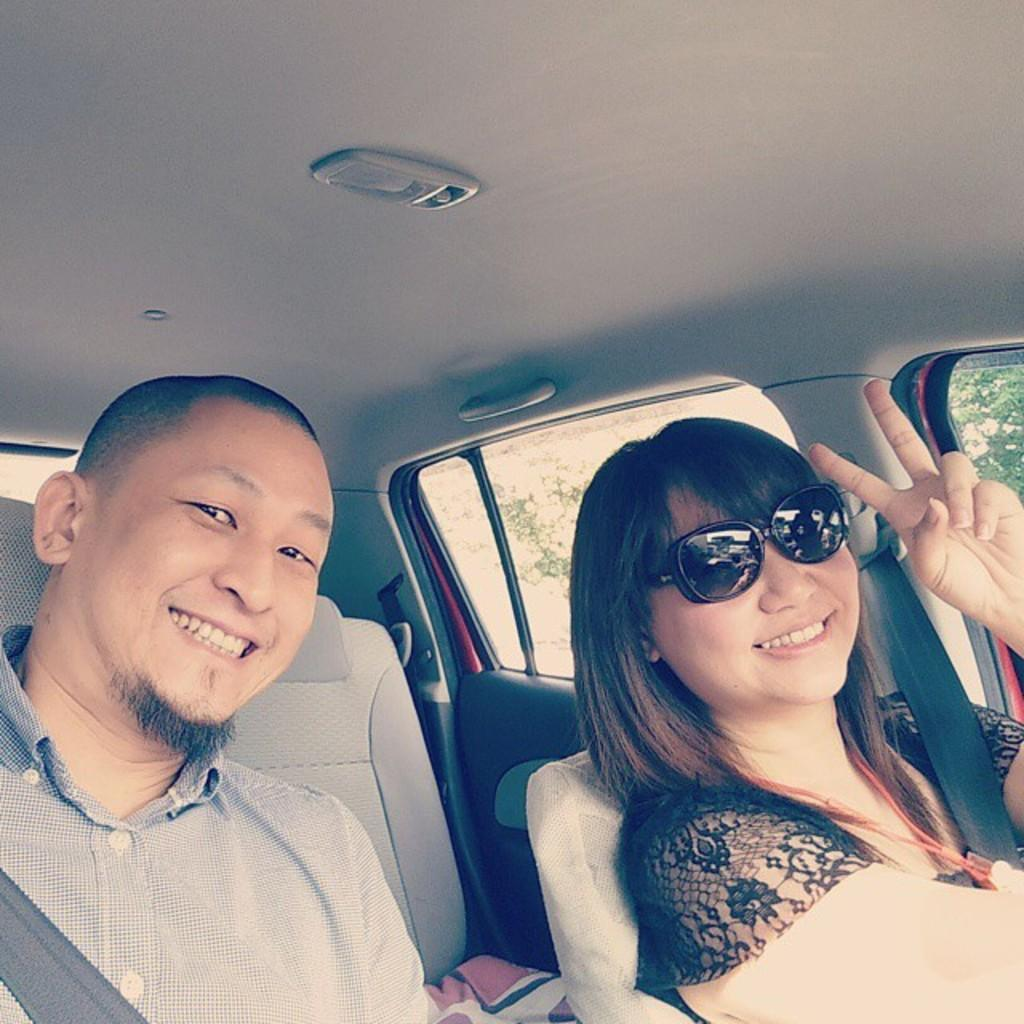How many people are in the image? There are two people in the image. What are the two people doing in the image? The two people are sitting in a car. What type of vegetable is being used as a calculator on the tray in the image? There is no vegetable, calculator, or tray present in the image. 